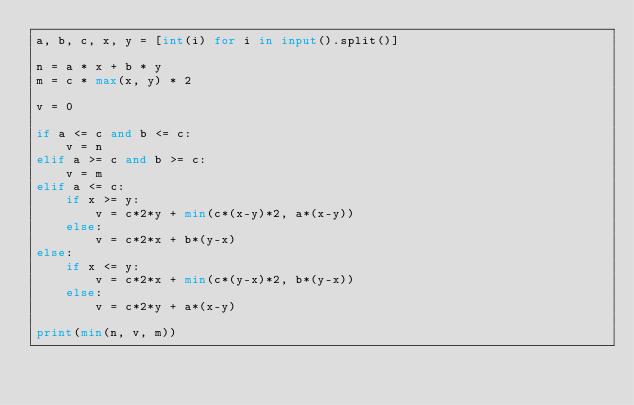<code> <loc_0><loc_0><loc_500><loc_500><_Python_>a, b, c, x, y = [int(i) for i in input().split()]

n = a * x + b * y
m = c * max(x, y) * 2

v = 0

if a <= c and b <= c:
    v = n
elif a >= c and b >= c:
    v = m
elif a <= c:
    if x >= y:
        v = c*2*y + min(c*(x-y)*2, a*(x-y))
    else:
        v = c*2*x + b*(y-x)
else:
    if x <= y:
        v = c*2*x + min(c*(y-x)*2, b*(y-x))
    else:
        v = c*2*y + a*(x-y)

print(min(n, v, m))</code> 